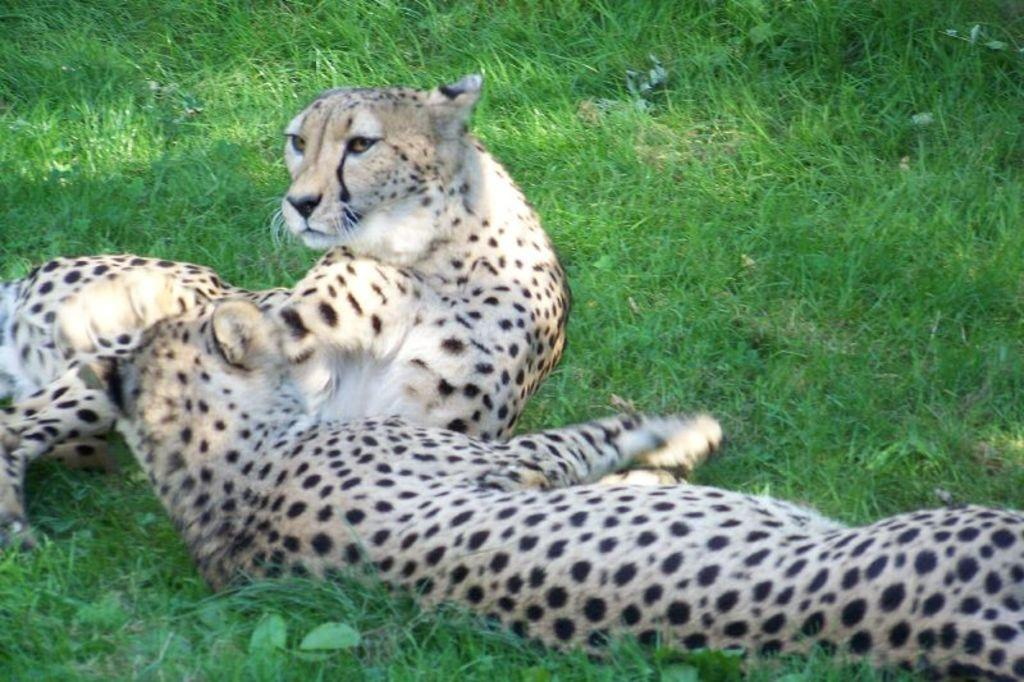What animals are present in the image? There are two leopards in the image. What is the leopards' location in the image? The leopards are on the grass. What type of rabbit can be seen hopping in the image? There is no rabbit present in the image; it features two leopards on the grass. What kind of toad is visible in the image? There is no toad present in the image; it features two leopards on the grass. 